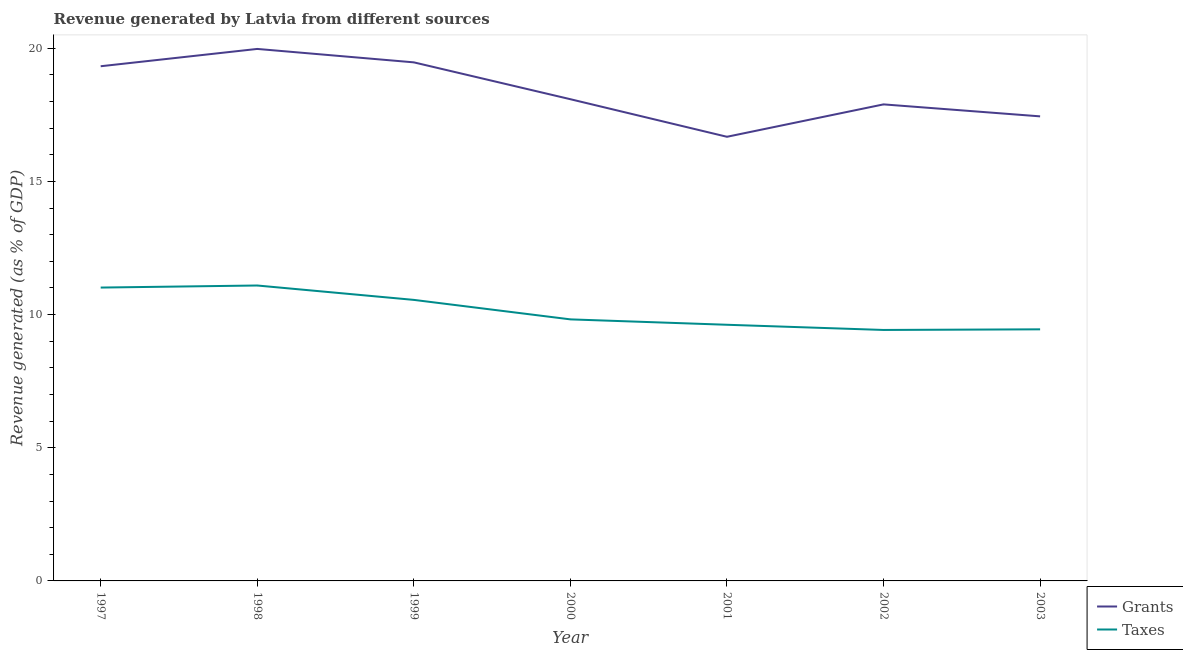How many different coloured lines are there?
Provide a short and direct response. 2. What is the revenue generated by grants in 2000?
Give a very brief answer. 18.09. Across all years, what is the maximum revenue generated by taxes?
Ensure brevity in your answer.  11.09. Across all years, what is the minimum revenue generated by taxes?
Provide a succinct answer. 9.42. In which year was the revenue generated by taxes maximum?
Give a very brief answer. 1998. In which year was the revenue generated by grants minimum?
Provide a succinct answer. 2001. What is the total revenue generated by taxes in the graph?
Make the answer very short. 70.97. What is the difference between the revenue generated by grants in 1997 and that in 1998?
Your answer should be very brief. -0.65. What is the difference between the revenue generated by taxes in 1998 and the revenue generated by grants in 2001?
Give a very brief answer. -5.58. What is the average revenue generated by grants per year?
Ensure brevity in your answer.  18.41. In the year 1997, what is the difference between the revenue generated by grants and revenue generated by taxes?
Provide a succinct answer. 8.31. What is the ratio of the revenue generated by taxes in 1998 to that in 2003?
Give a very brief answer. 1.17. Is the difference between the revenue generated by grants in 1999 and 2002 greater than the difference between the revenue generated by taxes in 1999 and 2002?
Your answer should be very brief. Yes. What is the difference between the highest and the second highest revenue generated by grants?
Provide a succinct answer. 0.5. What is the difference between the highest and the lowest revenue generated by taxes?
Provide a succinct answer. 1.67. In how many years, is the revenue generated by grants greater than the average revenue generated by grants taken over all years?
Give a very brief answer. 3. Is the sum of the revenue generated by taxes in 1998 and 2001 greater than the maximum revenue generated by grants across all years?
Your response must be concise. Yes. What is the difference between two consecutive major ticks on the Y-axis?
Offer a terse response. 5. Does the graph contain any zero values?
Your response must be concise. No. Does the graph contain grids?
Keep it short and to the point. No. Where does the legend appear in the graph?
Your answer should be very brief. Bottom right. What is the title of the graph?
Your answer should be very brief. Revenue generated by Latvia from different sources. What is the label or title of the X-axis?
Keep it short and to the point. Year. What is the label or title of the Y-axis?
Your response must be concise. Revenue generated (as % of GDP). What is the Revenue generated (as % of GDP) of Grants in 1997?
Your answer should be very brief. 19.33. What is the Revenue generated (as % of GDP) in Taxes in 1997?
Offer a very short reply. 11.02. What is the Revenue generated (as % of GDP) of Grants in 1998?
Provide a succinct answer. 19.98. What is the Revenue generated (as % of GDP) of Taxes in 1998?
Provide a short and direct response. 11.09. What is the Revenue generated (as % of GDP) of Grants in 1999?
Your answer should be very brief. 19.47. What is the Revenue generated (as % of GDP) in Taxes in 1999?
Make the answer very short. 10.55. What is the Revenue generated (as % of GDP) in Grants in 2000?
Keep it short and to the point. 18.09. What is the Revenue generated (as % of GDP) in Taxes in 2000?
Your answer should be compact. 9.82. What is the Revenue generated (as % of GDP) in Grants in 2001?
Your response must be concise. 16.68. What is the Revenue generated (as % of GDP) of Taxes in 2001?
Keep it short and to the point. 9.62. What is the Revenue generated (as % of GDP) of Grants in 2002?
Provide a short and direct response. 17.89. What is the Revenue generated (as % of GDP) in Taxes in 2002?
Offer a terse response. 9.42. What is the Revenue generated (as % of GDP) of Grants in 2003?
Make the answer very short. 17.44. What is the Revenue generated (as % of GDP) of Taxes in 2003?
Your answer should be very brief. 9.45. Across all years, what is the maximum Revenue generated (as % of GDP) in Grants?
Provide a succinct answer. 19.98. Across all years, what is the maximum Revenue generated (as % of GDP) in Taxes?
Provide a short and direct response. 11.09. Across all years, what is the minimum Revenue generated (as % of GDP) in Grants?
Your answer should be very brief. 16.68. Across all years, what is the minimum Revenue generated (as % of GDP) of Taxes?
Your response must be concise. 9.42. What is the total Revenue generated (as % of GDP) of Grants in the graph?
Make the answer very short. 128.87. What is the total Revenue generated (as % of GDP) in Taxes in the graph?
Make the answer very short. 70.97. What is the difference between the Revenue generated (as % of GDP) in Grants in 1997 and that in 1998?
Offer a terse response. -0.65. What is the difference between the Revenue generated (as % of GDP) of Taxes in 1997 and that in 1998?
Offer a terse response. -0.08. What is the difference between the Revenue generated (as % of GDP) in Grants in 1997 and that in 1999?
Give a very brief answer. -0.15. What is the difference between the Revenue generated (as % of GDP) of Taxes in 1997 and that in 1999?
Offer a very short reply. 0.46. What is the difference between the Revenue generated (as % of GDP) in Grants in 1997 and that in 2000?
Provide a succinct answer. 1.24. What is the difference between the Revenue generated (as % of GDP) of Taxes in 1997 and that in 2000?
Provide a short and direct response. 1.19. What is the difference between the Revenue generated (as % of GDP) in Grants in 1997 and that in 2001?
Offer a terse response. 2.65. What is the difference between the Revenue generated (as % of GDP) of Taxes in 1997 and that in 2001?
Offer a terse response. 1.4. What is the difference between the Revenue generated (as % of GDP) of Grants in 1997 and that in 2002?
Offer a very short reply. 1.43. What is the difference between the Revenue generated (as % of GDP) of Taxes in 1997 and that in 2002?
Your answer should be compact. 1.59. What is the difference between the Revenue generated (as % of GDP) of Grants in 1997 and that in 2003?
Your response must be concise. 1.88. What is the difference between the Revenue generated (as % of GDP) in Taxes in 1997 and that in 2003?
Give a very brief answer. 1.57. What is the difference between the Revenue generated (as % of GDP) of Grants in 1998 and that in 1999?
Keep it short and to the point. 0.5. What is the difference between the Revenue generated (as % of GDP) of Taxes in 1998 and that in 1999?
Offer a very short reply. 0.54. What is the difference between the Revenue generated (as % of GDP) of Grants in 1998 and that in 2000?
Offer a terse response. 1.89. What is the difference between the Revenue generated (as % of GDP) in Taxes in 1998 and that in 2000?
Provide a succinct answer. 1.27. What is the difference between the Revenue generated (as % of GDP) in Grants in 1998 and that in 2001?
Your response must be concise. 3.3. What is the difference between the Revenue generated (as % of GDP) of Taxes in 1998 and that in 2001?
Offer a very short reply. 1.47. What is the difference between the Revenue generated (as % of GDP) of Grants in 1998 and that in 2002?
Give a very brief answer. 2.08. What is the difference between the Revenue generated (as % of GDP) in Taxes in 1998 and that in 2002?
Offer a terse response. 1.67. What is the difference between the Revenue generated (as % of GDP) in Grants in 1998 and that in 2003?
Your answer should be compact. 2.53. What is the difference between the Revenue generated (as % of GDP) in Taxes in 1998 and that in 2003?
Offer a very short reply. 1.65. What is the difference between the Revenue generated (as % of GDP) of Grants in 1999 and that in 2000?
Offer a very short reply. 1.38. What is the difference between the Revenue generated (as % of GDP) of Taxes in 1999 and that in 2000?
Your answer should be compact. 0.73. What is the difference between the Revenue generated (as % of GDP) in Grants in 1999 and that in 2001?
Make the answer very short. 2.79. What is the difference between the Revenue generated (as % of GDP) of Taxes in 1999 and that in 2001?
Your answer should be very brief. 0.93. What is the difference between the Revenue generated (as % of GDP) in Grants in 1999 and that in 2002?
Offer a terse response. 1.58. What is the difference between the Revenue generated (as % of GDP) in Taxes in 1999 and that in 2002?
Provide a short and direct response. 1.13. What is the difference between the Revenue generated (as % of GDP) of Grants in 1999 and that in 2003?
Keep it short and to the point. 2.03. What is the difference between the Revenue generated (as % of GDP) in Taxes in 1999 and that in 2003?
Ensure brevity in your answer.  1.11. What is the difference between the Revenue generated (as % of GDP) in Grants in 2000 and that in 2001?
Offer a terse response. 1.41. What is the difference between the Revenue generated (as % of GDP) of Taxes in 2000 and that in 2001?
Your answer should be very brief. 0.2. What is the difference between the Revenue generated (as % of GDP) in Grants in 2000 and that in 2002?
Your answer should be compact. 0.19. What is the difference between the Revenue generated (as % of GDP) in Taxes in 2000 and that in 2002?
Your answer should be compact. 0.4. What is the difference between the Revenue generated (as % of GDP) of Grants in 2000 and that in 2003?
Make the answer very short. 0.64. What is the difference between the Revenue generated (as % of GDP) of Taxes in 2000 and that in 2003?
Offer a terse response. 0.37. What is the difference between the Revenue generated (as % of GDP) of Grants in 2001 and that in 2002?
Your response must be concise. -1.22. What is the difference between the Revenue generated (as % of GDP) in Taxes in 2001 and that in 2002?
Your response must be concise. 0.19. What is the difference between the Revenue generated (as % of GDP) of Grants in 2001 and that in 2003?
Your response must be concise. -0.77. What is the difference between the Revenue generated (as % of GDP) in Taxes in 2001 and that in 2003?
Your answer should be very brief. 0.17. What is the difference between the Revenue generated (as % of GDP) of Grants in 2002 and that in 2003?
Ensure brevity in your answer.  0.45. What is the difference between the Revenue generated (as % of GDP) of Taxes in 2002 and that in 2003?
Keep it short and to the point. -0.02. What is the difference between the Revenue generated (as % of GDP) in Grants in 1997 and the Revenue generated (as % of GDP) in Taxes in 1998?
Keep it short and to the point. 8.23. What is the difference between the Revenue generated (as % of GDP) of Grants in 1997 and the Revenue generated (as % of GDP) of Taxes in 1999?
Provide a succinct answer. 8.77. What is the difference between the Revenue generated (as % of GDP) of Grants in 1997 and the Revenue generated (as % of GDP) of Taxes in 2000?
Make the answer very short. 9.5. What is the difference between the Revenue generated (as % of GDP) in Grants in 1997 and the Revenue generated (as % of GDP) in Taxes in 2001?
Give a very brief answer. 9.71. What is the difference between the Revenue generated (as % of GDP) of Grants in 1997 and the Revenue generated (as % of GDP) of Taxes in 2002?
Offer a very short reply. 9.9. What is the difference between the Revenue generated (as % of GDP) of Grants in 1997 and the Revenue generated (as % of GDP) of Taxes in 2003?
Provide a short and direct response. 9.88. What is the difference between the Revenue generated (as % of GDP) of Grants in 1998 and the Revenue generated (as % of GDP) of Taxes in 1999?
Offer a very short reply. 9.42. What is the difference between the Revenue generated (as % of GDP) of Grants in 1998 and the Revenue generated (as % of GDP) of Taxes in 2000?
Keep it short and to the point. 10.15. What is the difference between the Revenue generated (as % of GDP) in Grants in 1998 and the Revenue generated (as % of GDP) in Taxes in 2001?
Offer a terse response. 10.36. What is the difference between the Revenue generated (as % of GDP) of Grants in 1998 and the Revenue generated (as % of GDP) of Taxes in 2002?
Give a very brief answer. 10.55. What is the difference between the Revenue generated (as % of GDP) of Grants in 1998 and the Revenue generated (as % of GDP) of Taxes in 2003?
Your response must be concise. 10.53. What is the difference between the Revenue generated (as % of GDP) in Grants in 1999 and the Revenue generated (as % of GDP) in Taxes in 2000?
Your answer should be very brief. 9.65. What is the difference between the Revenue generated (as % of GDP) of Grants in 1999 and the Revenue generated (as % of GDP) of Taxes in 2001?
Your answer should be compact. 9.85. What is the difference between the Revenue generated (as % of GDP) of Grants in 1999 and the Revenue generated (as % of GDP) of Taxes in 2002?
Ensure brevity in your answer.  10.05. What is the difference between the Revenue generated (as % of GDP) in Grants in 1999 and the Revenue generated (as % of GDP) in Taxes in 2003?
Offer a terse response. 10.02. What is the difference between the Revenue generated (as % of GDP) of Grants in 2000 and the Revenue generated (as % of GDP) of Taxes in 2001?
Offer a terse response. 8.47. What is the difference between the Revenue generated (as % of GDP) in Grants in 2000 and the Revenue generated (as % of GDP) in Taxes in 2002?
Your answer should be very brief. 8.66. What is the difference between the Revenue generated (as % of GDP) of Grants in 2000 and the Revenue generated (as % of GDP) of Taxes in 2003?
Offer a terse response. 8.64. What is the difference between the Revenue generated (as % of GDP) of Grants in 2001 and the Revenue generated (as % of GDP) of Taxes in 2002?
Offer a very short reply. 7.25. What is the difference between the Revenue generated (as % of GDP) in Grants in 2001 and the Revenue generated (as % of GDP) in Taxes in 2003?
Provide a succinct answer. 7.23. What is the difference between the Revenue generated (as % of GDP) in Grants in 2002 and the Revenue generated (as % of GDP) in Taxes in 2003?
Your response must be concise. 8.45. What is the average Revenue generated (as % of GDP) of Grants per year?
Make the answer very short. 18.41. What is the average Revenue generated (as % of GDP) of Taxes per year?
Provide a short and direct response. 10.14. In the year 1997, what is the difference between the Revenue generated (as % of GDP) of Grants and Revenue generated (as % of GDP) of Taxes?
Offer a terse response. 8.31. In the year 1998, what is the difference between the Revenue generated (as % of GDP) in Grants and Revenue generated (as % of GDP) in Taxes?
Provide a short and direct response. 8.88. In the year 1999, what is the difference between the Revenue generated (as % of GDP) of Grants and Revenue generated (as % of GDP) of Taxes?
Offer a very short reply. 8.92. In the year 2000, what is the difference between the Revenue generated (as % of GDP) of Grants and Revenue generated (as % of GDP) of Taxes?
Your response must be concise. 8.27. In the year 2001, what is the difference between the Revenue generated (as % of GDP) in Grants and Revenue generated (as % of GDP) in Taxes?
Your answer should be compact. 7.06. In the year 2002, what is the difference between the Revenue generated (as % of GDP) of Grants and Revenue generated (as % of GDP) of Taxes?
Provide a succinct answer. 8.47. In the year 2003, what is the difference between the Revenue generated (as % of GDP) of Grants and Revenue generated (as % of GDP) of Taxes?
Offer a very short reply. 8. What is the ratio of the Revenue generated (as % of GDP) of Grants in 1997 to that in 1998?
Your answer should be very brief. 0.97. What is the ratio of the Revenue generated (as % of GDP) in Taxes in 1997 to that in 1998?
Give a very brief answer. 0.99. What is the ratio of the Revenue generated (as % of GDP) in Grants in 1997 to that in 1999?
Keep it short and to the point. 0.99. What is the ratio of the Revenue generated (as % of GDP) of Taxes in 1997 to that in 1999?
Provide a succinct answer. 1.04. What is the ratio of the Revenue generated (as % of GDP) in Grants in 1997 to that in 2000?
Offer a very short reply. 1.07. What is the ratio of the Revenue generated (as % of GDP) in Taxes in 1997 to that in 2000?
Ensure brevity in your answer.  1.12. What is the ratio of the Revenue generated (as % of GDP) of Grants in 1997 to that in 2001?
Offer a very short reply. 1.16. What is the ratio of the Revenue generated (as % of GDP) in Taxes in 1997 to that in 2001?
Make the answer very short. 1.15. What is the ratio of the Revenue generated (as % of GDP) in Taxes in 1997 to that in 2002?
Your answer should be compact. 1.17. What is the ratio of the Revenue generated (as % of GDP) of Grants in 1997 to that in 2003?
Your response must be concise. 1.11. What is the ratio of the Revenue generated (as % of GDP) in Taxes in 1997 to that in 2003?
Give a very brief answer. 1.17. What is the ratio of the Revenue generated (as % of GDP) in Grants in 1998 to that in 1999?
Make the answer very short. 1.03. What is the ratio of the Revenue generated (as % of GDP) in Taxes in 1998 to that in 1999?
Give a very brief answer. 1.05. What is the ratio of the Revenue generated (as % of GDP) in Grants in 1998 to that in 2000?
Your response must be concise. 1.1. What is the ratio of the Revenue generated (as % of GDP) in Taxes in 1998 to that in 2000?
Offer a very short reply. 1.13. What is the ratio of the Revenue generated (as % of GDP) of Grants in 1998 to that in 2001?
Ensure brevity in your answer.  1.2. What is the ratio of the Revenue generated (as % of GDP) in Taxes in 1998 to that in 2001?
Your response must be concise. 1.15. What is the ratio of the Revenue generated (as % of GDP) of Grants in 1998 to that in 2002?
Provide a short and direct response. 1.12. What is the ratio of the Revenue generated (as % of GDP) of Taxes in 1998 to that in 2002?
Your answer should be very brief. 1.18. What is the ratio of the Revenue generated (as % of GDP) in Grants in 1998 to that in 2003?
Provide a short and direct response. 1.15. What is the ratio of the Revenue generated (as % of GDP) in Taxes in 1998 to that in 2003?
Make the answer very short. 1.17. What is the ratio of the Revenue generated (as % of GDP) of Grants in 1999 to that in 2000?
Keep it short and to the point. 1.08. What is the ratio of the Revenue generated (as % of GDP) of Taxes in 1999 to that in 2000?
Your answer should be compact. 1.07. What is the ratio of the Revenue generated (as % of GDP) in Grants in 1999 to that in 2001?
Provide a succinct answer. 1.17. What is the ratio of the Revenue generated (as % of GDP) of Taxes in 1999 to that in 2001?
Offer a terse response. 1.1. What is the ratio of the Revenue generated (as % of GDP) of Grants in 1999 to that in 2002?
Keep it short and to the point. 1.09. What is the ratio of the Revenue generated (as % of GDP) in Taxes in 1999 to that in 2002?
Offer a very short reply. 1.12. What is the ratio of the Revenue generated (as % of GDP) in Grants in 1999 to that in 2003?
Ensure brevity in your answer.  1.12. What is the ratio of the Revenue generated (as % of GDP) of Taxes in 1999 to that in 2003?
Your answer should be compact. 1.12. What is the ratio of the Revenue generated (as % of GDP) in Grants in 2000 to that in 2001?
Give a very brief answer. 1.08. What is the ratio of the Revenue generated (as % of GDP) of Taxes in 2000 to that in 2001?
Give a very brief answer. 1.02. What is the ratio of the Revenue generated (as % of GDP) in Grants in 2000 to that in 2002?
Ensure brevity in your answer.  1.01. What is the ratio of the Revenue generated (as % of GDP) of Taxes in 2000 to that in 2002?
Give a very brief answer. 1.04. What is the ratio of the Revenue generated (as % of GDP) in Grants in 2000 to that in 2003?
Offer a terse response. 1.04. What is the ratio of the Revenue generated (as % of GDP) of Taxes in 2000 to that in 2003?
Ensure brevity in your answer.  1.04. What is the ratio of the Revenue generated (as % of GDP) in Grants in 2001 to that in 2002?
Ensure brevity in your answer.  0.93. What is the ratio of the Revenue generated (as % of GDP) in Taxes in 2001 to that in 2002?
Give a very brief answer. 1.02. What is the ratio of the Revenue generated (as % of GDP) of Grants in 2001 to that in 2003?
Your answer should be very brief. 0.96. What is the ratio of the Revenue generated (as % of GDP) of Taxes in 2001 to that in 2003?
Provide a short and direct response. 1.02. What is the ratio of the Revenue generated (as % of GDP) of Grants in 2002 to that in 2003?
Ensure brevity in your answer.  1.03. What is the ratio of the Revenue generated (as % of GDP) of Taxes in 2002 to that in 2003?
Your answer should be very brief. 1. What is the difference between the highest and the second highest Revenue generated (as % of GDP) of Grants?
Provide a succinct answer. 0.5. What is the difference between the highest and the second highest Revenue generated (as % of GDP) of Taxes?
Make the answer very short. 0.08. What is the difference between the highest and the lowest Revenue generated (as % of GDP) of Grants?
Give a very brief answer. 3.3. What is the difference between the highest and the lowest Revenue generated (as % of GDP) of Taxes?
Your answer should be compact. 1.67. 